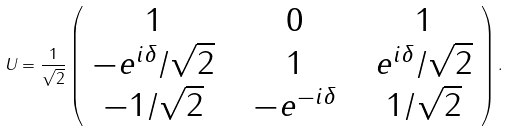Convert formula to latex. <formula><loc_0><loc_0><loc_500><loc_500>U = \frac { 1 } { \sqrt { 2 } } \left ( \begin{array} { c c c c c } 1 & { \, } & 0 & { \, } & 1 \\ - e ^ { i \delta } / \sqrt { 2 } & { \, } & 1 & { \, } & e ^ { i \delta } / \sqrt { 2 } \\ - 1 / \sqrt { 2 } & { \, } & - e ^ { - i \delta } & { \, } & 1 / \sqrt { 2 } \end{array} \right ) .</formula> 